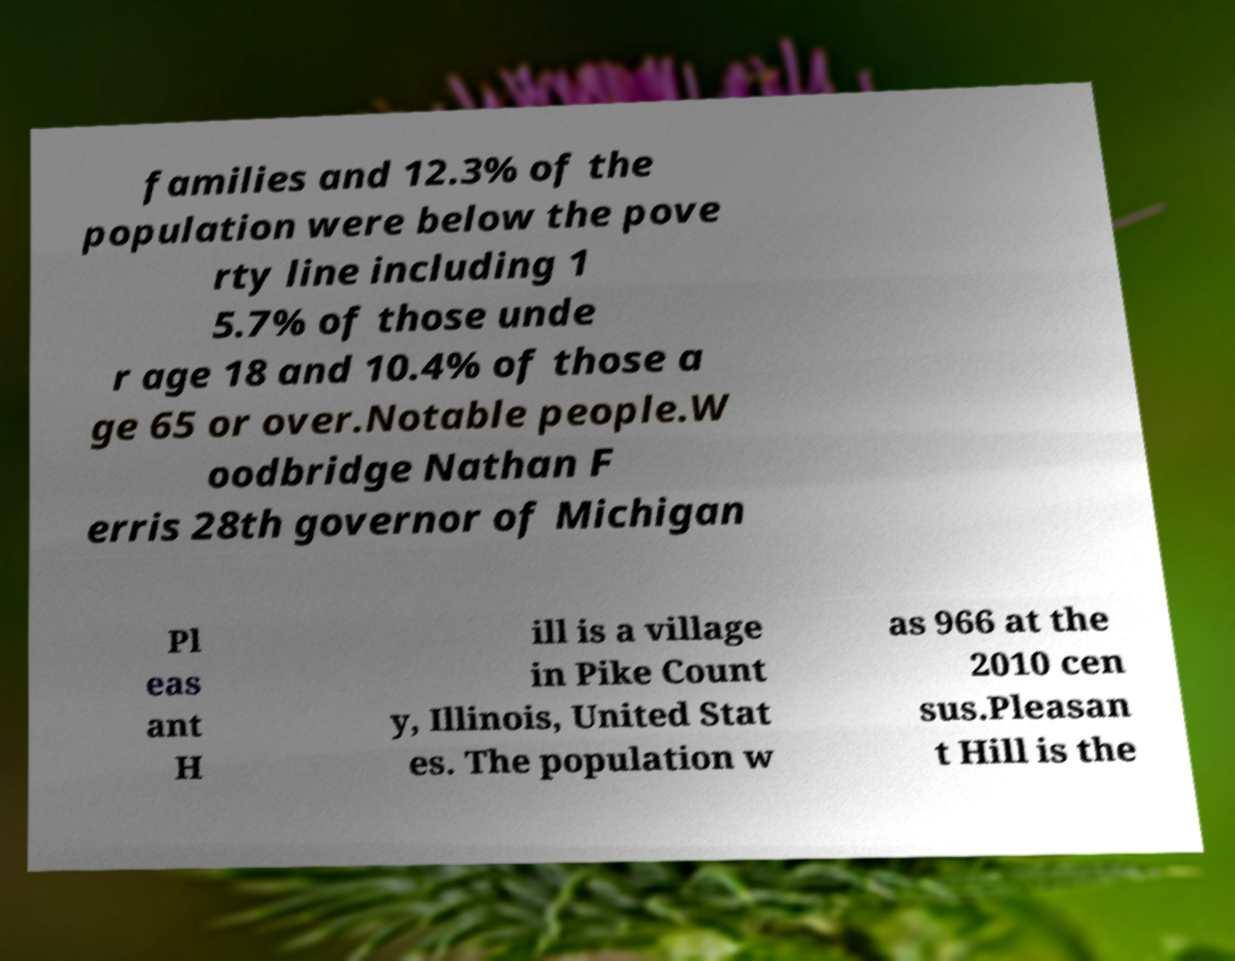What messages or text are displayed in this image? I need them in a readable, typed format. families and 12.3% of the population were below the pove rty line including 1 5.7% of those unde r age 18 and 10.4% of those a ge 65 or over.Notable people.W oodbridge Nathan F erris 28th governor of Michigan Pl eas ant H ill is a village in Pike Count y, Illinois, United Stat es. The population w as 966 at the 2010 cen sus.Pleasan t Hill is the 